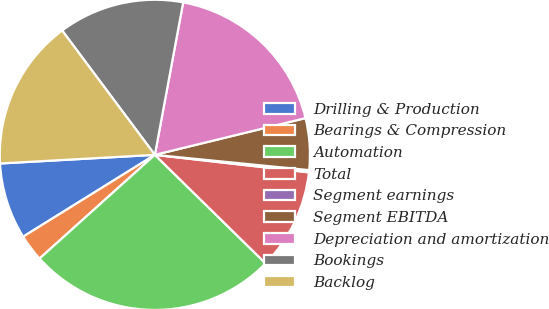Convert chart to OTSL. <chart><loc_0><loc_0><loc_500><loc_500><pie_chart><fcel>Drilling & Production<fcel>Bearings & Compression<fcel>Automation<fcel>Total<fcel>Segment earnings<fcel>Segment EBITDA<fcel>Depreciation and amortization<fcel>Bookings<fcel>Backlog<nl><fcel>7.96%<fcel>2.81%<fcel>26.0%<fcel>10.54%<fcel>0.23%<fcel>5.38%<fcel>18.27%<fcel>13.12%<fcel>15.69%<nl></chart> 